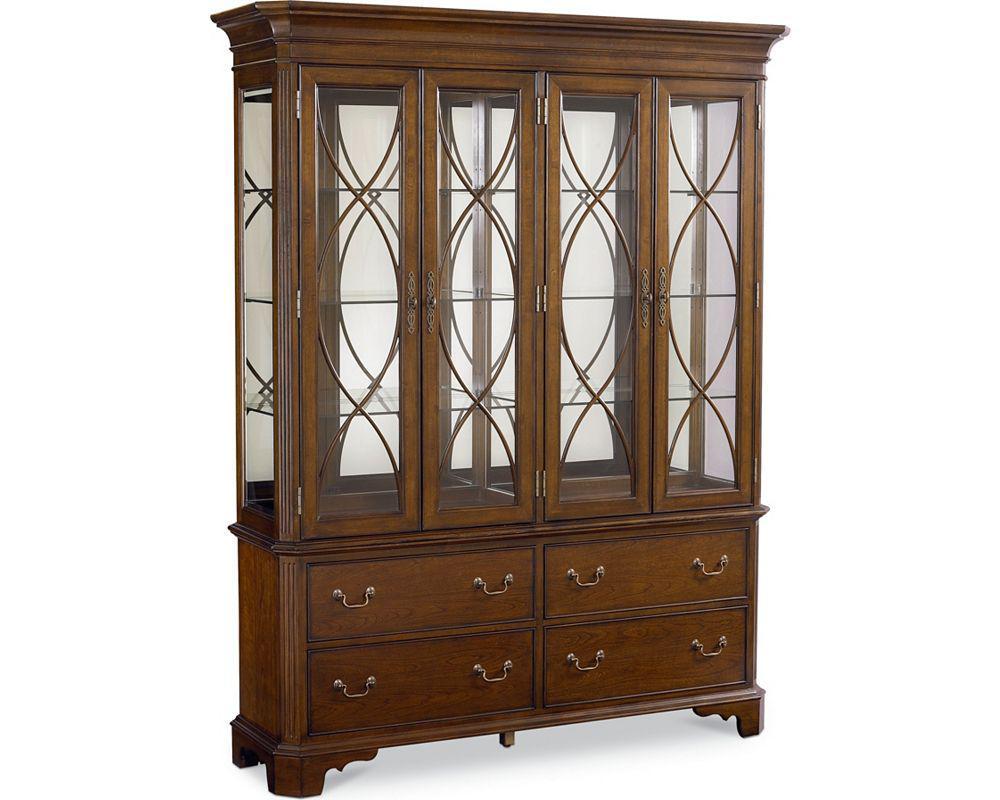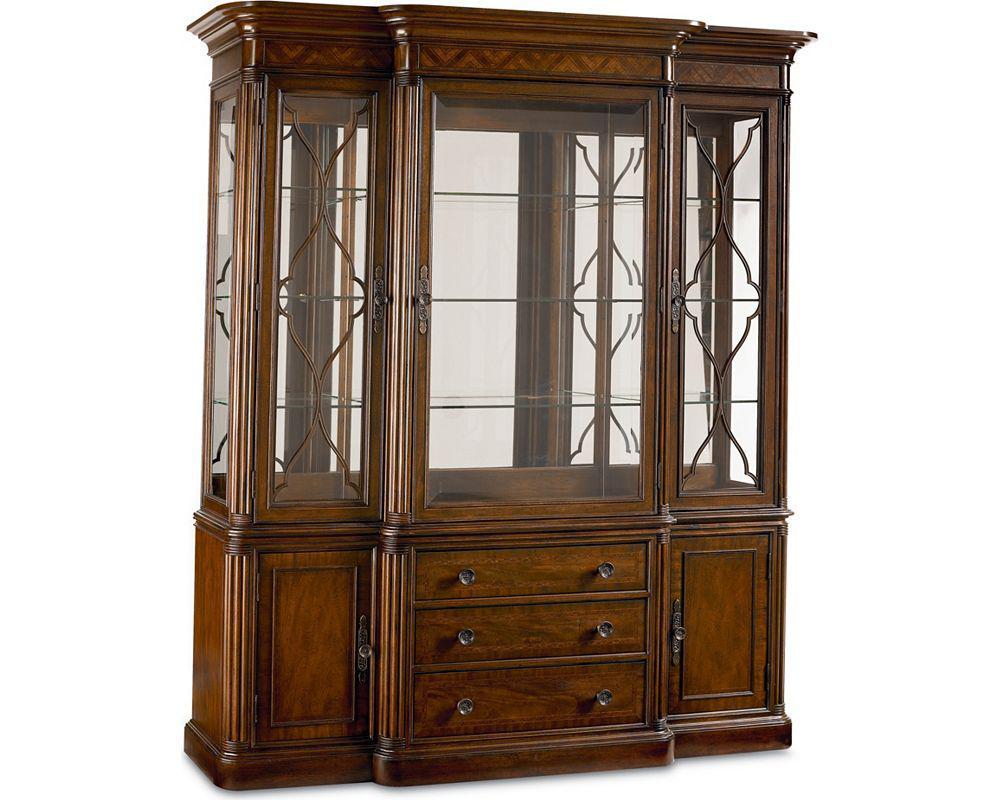The first image is the image on the left, the second image is the image on the right. For the images displayed, is the sentence "The right hand image has a row of three drawers." factually correct? Answer yes or no. Yes. 